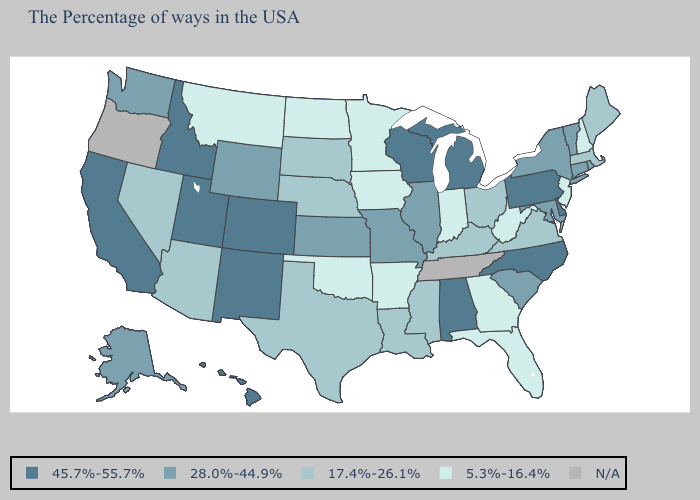Name the states that have a value in the range 28.0%-44.9%?
Short answer required. Rhode Island, Vermont, Connecticut, New York, Maryland, South Carolina, Illinois, Missouri, Kansas, Wyoming, Washington, Alaska. Name the states that have a value in the range N/A?
Write a very short answer. Tennessee, Oregon. What is the lowest value in the USA?
Quick response, please. 5.3%-16.4%. Which states hav the highest value in the MidWest?
Be succinct. Michigan, Wisconsin. Among the states that border Missouri , which have the highest value?
Answer briefly. Illinois, Kansas. What is the highest value in the USA?
Write a very short answer. 45.7%-55.7%. What is the lowest value in the West?
Give a very brief answer. 5.3%-16.4%. Among the states that border New Mexico , which have the lowest value?
Concise answer only. Oklahoma. What is the value of New Jersey?
Quick response, please. 5.3%-16.4%. Among the states that border Delaware , which have the highest value?
Concise answer only. Pennsylvania. Name the states that have a value in the range N/A?
Be succinct. Tennessee, Oregon. Among the states that border Rhode Island , which have the lowest value?
Be succinct. Massachusetts. Name the states that have a value in the range N/A?
Answer briefly. Tennessee, Oregon. What is the value of Idaho?
Concise answer only. 45.7%-55.7%. 